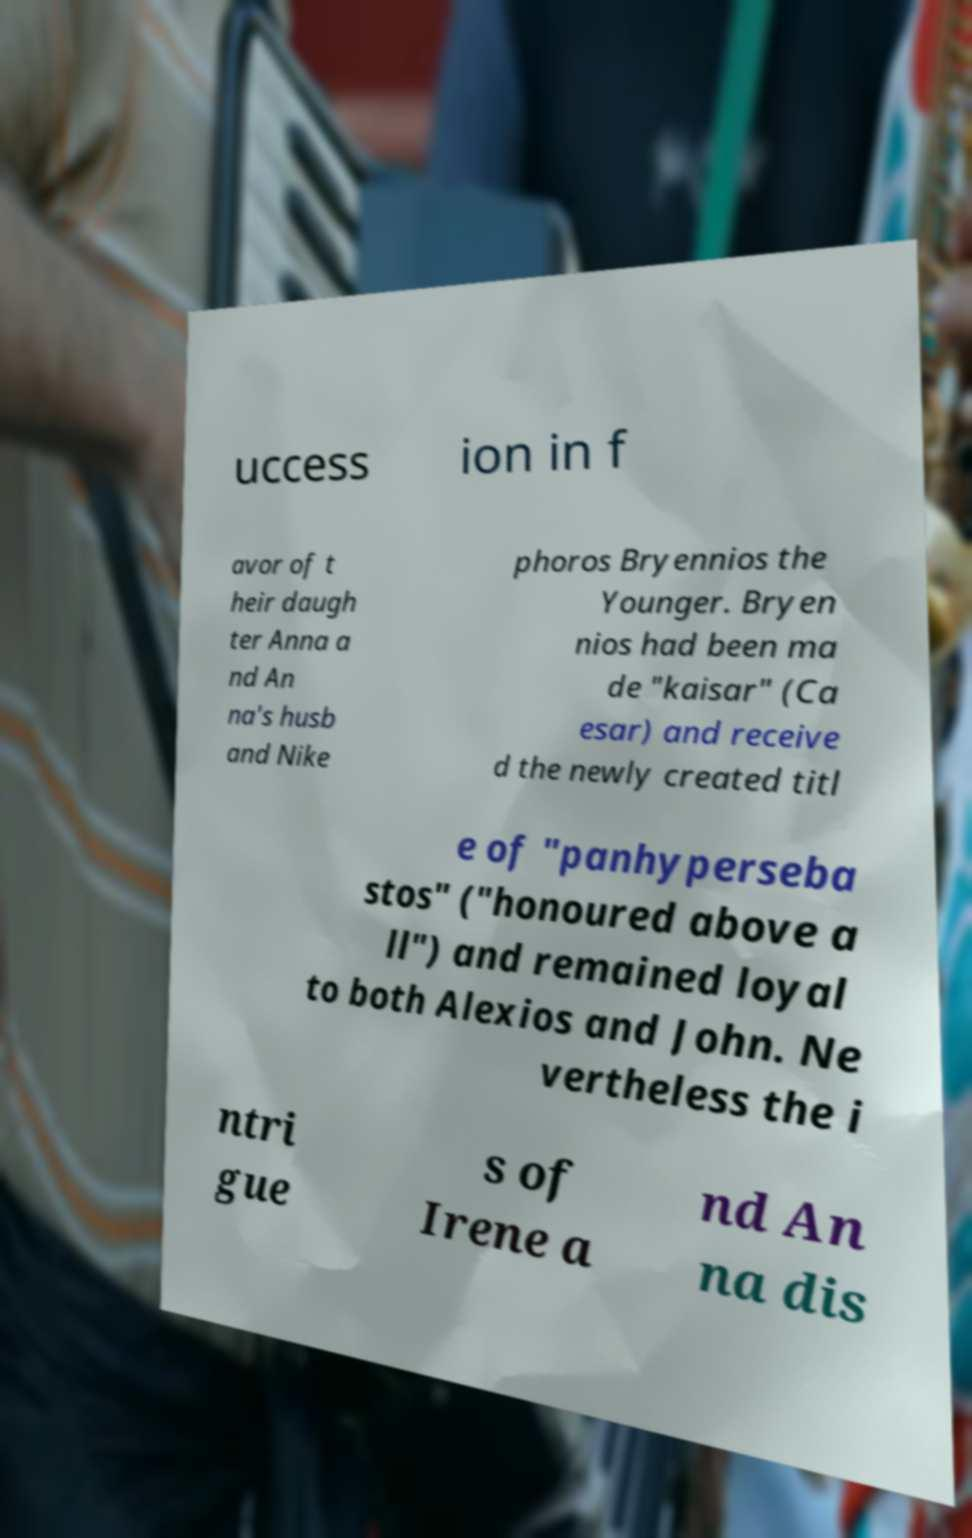Can you accurately transcribe the text from the provided image for me? uccess ion in f avor of t heir daugh ter Anna a nd An na's husb and Nike phoros Bryennios the Younger. Bryen nios had been ma de "kaisar" (Ca esar) and receive d the newly created titl e of "panhyperseba stos" ("honoured above a ll") and remained loyal to both Alexios and John. Ne vertheless the i ntri gue s of Irene a nd An na dis 